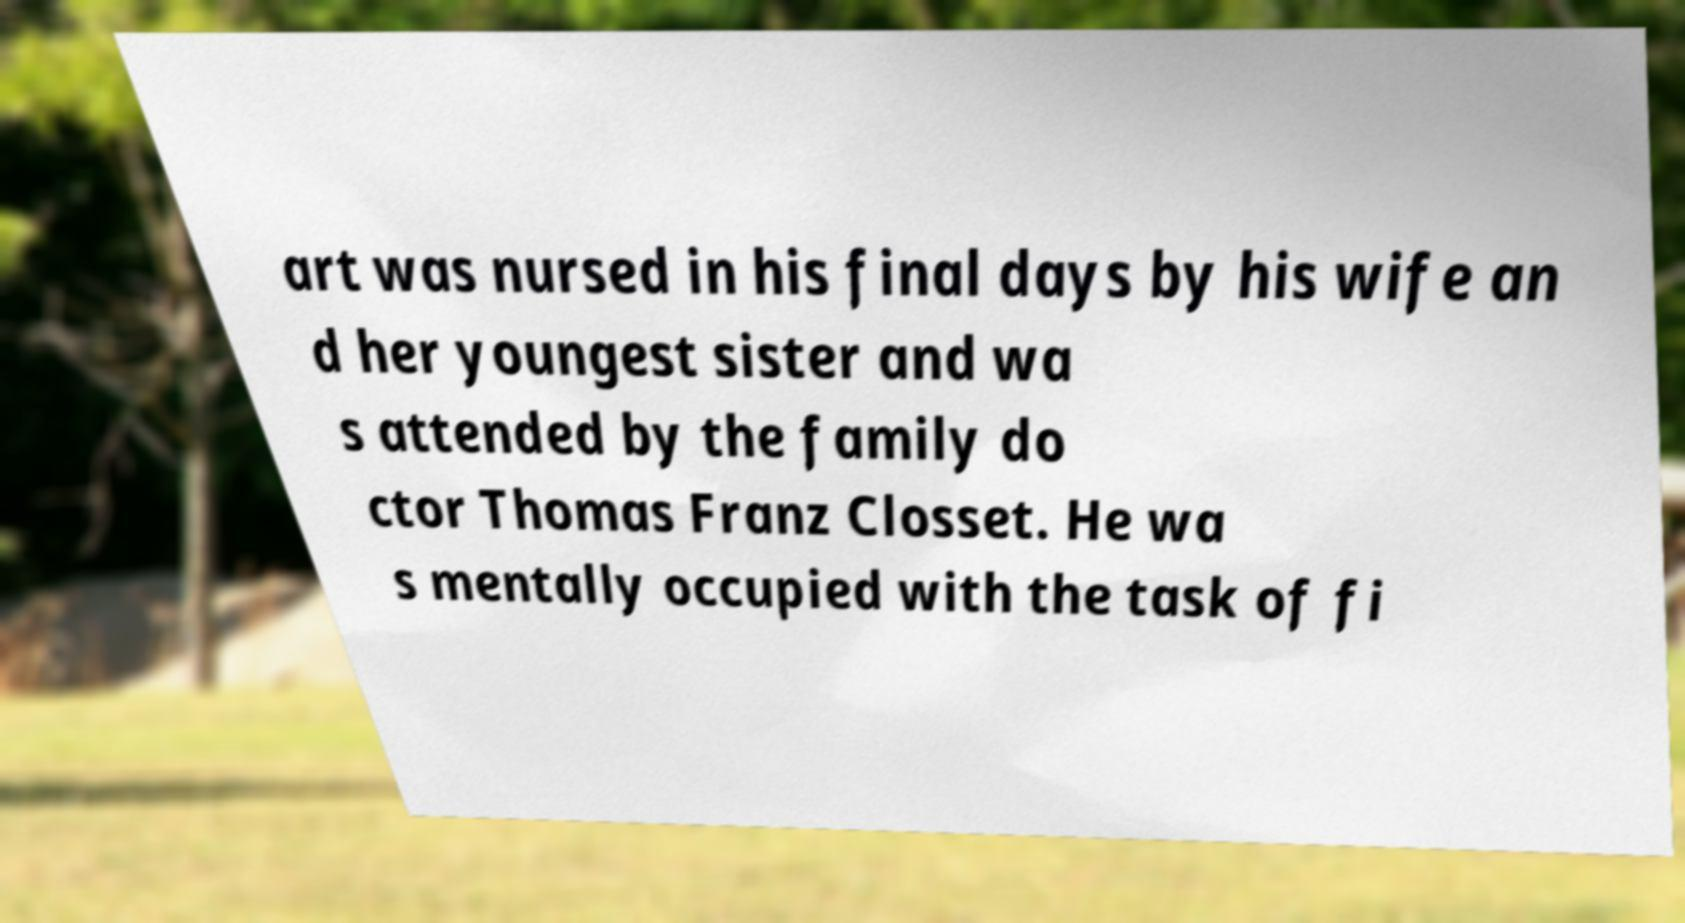Please identify and transcribe the text found in this image. art was nursed in his final days by his wife an d her youngest sister and wa s attended by the family do ctor Thomas Franz Closset. He wa s mentally occupied with the task of fi 